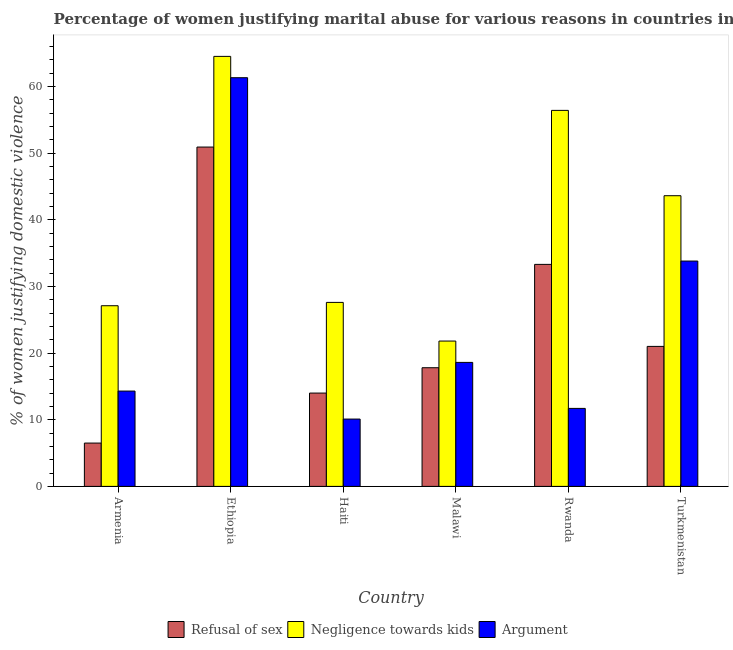How many different coloured bars are there?
Your answer should be compact. 3. How many groups of bars are there?
Your answer should be compact. 6. How many bars are there on the 6th tick from the right?
Ensure brevity in your answer.  3. What is the label of the 4th group of bars from the left?
Give a very brief answer. Malawi. In how many cases, is the number of bars for a given country not equal to the number of legend labels?
Your response must be concise. 0. What is the percentage of women justifying domestic violence due to arguments in Malawi?
Keep it short and to the point. 18.6. Across all countries, what is the maximum percentage of women justifying domestic violence due to refusal of sex?
Provide a short and direct response. 50.9. In which country was the percentage of women justifying domestic violence due to negligence towards kids maximum?
Your answer should be compact. Ethiopia. In which country was the percentage of women justifying domestic violence due to negligence towards kids minimum?
Offer a terse response. Malawi. What is the total percentage of women justifying domestic violence due to refusal of sex in the graph?
Your answer should be very brief. 143.5. What is the difference between the percentage of women justifying domestic violence due to refusal of sex in Armenia and that in Rwanda?
Give a very brief answer. -26.8. What is the difference between the percentage of women justifying domestic violence due to refusal of sex in Turkmenistan and the percentage of women justifying domestic violence due to arguments in Haiti?
Offer a terse response. 10.9. What is the average percentage of women justifying domestic violence due to refusal of sex per country?
Keep it short and to the point. 23.92. What is the difference between the percentage of women justifying domestic violence due to arguments and percentage of women justifying domestic violence due to refusal of sex in Turkmenistan?
Your answer should be very brief. 12.8. What is the ratio of the percentage of women justifying domestic violence due to arguments in Ethiopia to that in Haiti?
Keep it short and to the point. 6.07. Is the difference between the percentage of women justifying domestic violence due to arguments in Haiti and Turkmenistan greater than the difference between the percentage of women justifying domestic violence due to negligence towards kids in Haiti and Turkmenistan?
Your response must be concise. No. What is the difference between the highest and the lowest percentage of women justifying domestic violence due to refusal of sex?
Your answer should be very brief. 44.4. What does the 1st bar from the left in Rwanda represents?
Make the answer very short. Refusal of sex. What does the 2nd bar from the right in Armenia represents?
Your answer should be compact. Negligence towards kids. Is it the case that in every country, the sum of the percentage of women justifying domestic violence due to refusal of sex and percentage of women justifying domestic violence due to negligence towards kids is greater than the percentage of women justifying domestic violence due to arguments?
Provide a succinct answer. Yes. How many bars are there?
Provide a short and direct response. 18. What is the difference between two consecutive major ticks on the Y-axis?
Your response must be concise. 10. Are the values on the major ticks of Y-axis written in scientific E-notation?
Provide a short and direct response. No. Does the graph contain any zero values?
Keep it short and to the point. No. Does the graph contain grids?
Make the answer very short. No. Where does the legend appear in the graph?
Offer a very short reply. Bottom center. How are the legend labels stacked?
Provide a short and direct response. Horizontal. What is the title of the graph?
Keep it short and to the point. Percentage of women justifying marital abuse for various reasons in countries in 2000. Does "Ages 60+" appear as one of the legend labels in the graph?
Provide a succinct answer. No. What is the label or title of the Y-axis?
Give a very brief answer. % of women justifying domestic violence. What is the % of women justifying domestic violence of Refusal of sex in Armenia?
Your answer should be compact. 6.5. What is the % of women justifying domestic violence in Negligence towards kids in Armenia?
Your response must be concise. 27.1. What is the % of women justifying domestic violence in Refusal of sex in Ethiopia?
Give a very brief answer. 50.9. What is the % of women justifying domestic violence of Negligence towards kids in Ethiopia?
Your response must be concise. 64.5. What is the % of women justifying domestic violence in Argument in Ethiopia?
Make the answer very short. 61.3. What is the % of women justifying domestic violence of Refusal of sex in Haiti?
Ensure brevity in your answer.  14. What is the % of women justifying domestic violence in Negligence towards kids in Haiti?
Keep it short and to the point. 27.6. What is the % of women justifying domestic violence in Refusal of sex in Malawi?
Your answer should be compact. 17.8. What is the % of women justifying domestic violence of Negligence towards kids in Malawi?
Offer a terse response. 21.8. What is the % of women justifying domestic violence of Argument in Malawi?
Give a very brief answer. 18.6. What is the % of women justifying domestic violence of Refusal of sex in Rwanda?
Offer a very short reply. 33.3. What is the % of women justifying domestic violence in Negligence towards kids in Rwanda?
Give a very brief answer. 56.4. What is the % of women justifying domestic violence in Argument in Rwanda?
Keep it short and to the point. 11.7. What is the % of women justifying domestic violence of Refusal of sex in Turkmenistan?
Your response must be concise. 21. What is the % of women justifying domestic violence in Negligence towards kids in Turkmenistan?
Offer a terse response. 43.6. What is the % of women justifying domestic violence of Argument in Turkmenistan?
Provide a short and direct response. 33.8. Across all countries, what is the maximum % of women justifying domestic violence of Refusal of sex?
Your response must be concise. 50.9. Across all countries, what is the maximum % of women justifying domestic violence of Negligence towards kids?
Your answer should be very brief. 64.5. Across all countries, what is the maximum % of women justifying domestic violence of Argument?
Provide a short and direct response. 61.3. Across all countries, what is the minimum % of women justifying domestic violence in Negligence towards kids?
Keep it short and to the point. 21.8. Across all countries, what is the minimum % of women justifying domestic violence of Argument?
Ensure brevity in your answer.  10.1. What is the total % of women justifying domestic violence of Refusal of sex in the graph?
Offer a very short reply. 143.5. What is the total % of women justifying domestic violence in Negligence towards kids in the graph?
Ensure brevity in your answer.  241. What is the total % of women justifying domestic violence in Argument in the graph?
Your response must be concise. 149.8. What is the difference between the % of women justifying domestic violence of Refusal of sex in Armenia and that in Ethiopia?
Your answer should be very brief. -44.4. What is the difference between the % of women justifying domestic violence of Negligence towards kids in Armenia and that in Ethiopia?
Your response must be concise. -37.4. What is the difference between the % of women justifying domestic violence of Argument in Armenia and that in Ethiopia?
Offer a terse response. -47. What is the difference between the % of women justifying domestic violence in Negligence towards kids in Armenia and that in Haiti?
Your answer should be very brief. -0.5. What is the difference between the % of women justifying domestic violence of Argument in Armenia and that in Haiti?
Offer a very short reply. 4.2. What is the difference between the % of women justifying domestic violence in Refusal of sex in Armenia and that in Malawi?
Provide a succinct answer. -11.3. What is the difference between the % of women justifying domestic violence in Negligence towards kids in Armenia and that in Malawi?
Your answer should be very brief. 5.3. What is the difference between the % of women justifying domestic violence of Argument in Armenia and that in Malawi?
Ensure brevity in your answer.  -4.3. What is the difference between the % of women justifying domestic violence of Refusal of sex in Armenia and that in Rwanda?
Provide a succinct answer. -26.8. What is the difference between the % of women justifying domestic violence in Negligence towards kids in Armenia and that in Rwanda?
Ensure brevity in your answer.  -29.3. What is the difference between the % of women justifying domestic violence of Argument in Armenia and that in Rwanda?
Make the answer very short. 2.6. What is the difference between the % of women justifying domestic violence of Refusal of sex in Armenia and that in Turkmenistan?
Give a very brief answer. -14.5. What is the difference between the % of women justifying domestic violence in Negligence towards kids in Armenia and that in Turkmenistan?
Your answer should be compact. -16.5. What is the difference between the % of women justifying domestic violence of Argument in Armenia and that in Turkmenistan?
Offer a very short reply. -19.5. What is the difference between the % of women justifying domestic violence in Refusal of sex in Ethiopia and that in Haiti?
Give a very brief answer. 36.9. What is the difference between the % of women justifying domestic violence of Negligence towards kids in Ethiopia and that in Haiti?
Your response must be concise. 36.9. What is the difference between the % of women justifying domestic violence in Argument in Ethiopia and that in Haiti?
Keep it short and to the point. 51.2. What is the difference between the % of women justifying domestic violence in Refusal of sex in Ethiopia and that in Malawi?
Offer a terse response. 33.1. What is the difference between the % of women justifying domestic violence of Negligence towards kids in Ethiopia and that in Malawi?
Keep it short and to the point. 42.7. What is the difference between the % of women justifying domestic violence of Argument in Ethiopia and that in Malawi?
Provide a short and direct response. 42.7. What is the difference between the % of women justifying domestic violence in Refusal of sex in Ethiopia and that in Rwanda?
Provide a succinct answer. 17.6. What is the difference between the % of women justifying domestic violence of Argument in Ethiopia and that in Rwanda?
Your answer should be very brief. 49.6. What is the difference between the % of women justifying domestic violence in Refusal of sex in Ethiopia and that in Turkmenistan?
Provide a short and direct response. 29.9. What is the difference between the % of women justifying domestic violence in Negligence towards kids in Ethiopia and that in Turkmenistan?
Provide a succinct answer. 20.9. What is the difference between the % of women justifying domestic violence in Argument in Ethiopia and that in Turkmenistan?
Your answer should be compact. 27.5. What is the difference between the % of women justifying domestic violence in Negligence towards kids in Haiti and that in Malawi?
Make the answer very short. 5.8. What is the difference between the % of women justifying domestic violence of Refusal of sex in Haiti and that in Rwanda?
Offer a terse response. -19.3. What is the difference between the % of women justifying domestic violence in Negligence towards kids in Haiti and that in Rwanda?
Give a very brief answer. -28.8. What is the difference between the % of women justifying domestic violence in Argument in Haiti and that in Rwanda?
Your answer should be very brief. -1.6. What is the difference between the % of women justifying domestic violence of Argument in Haiti and that in Turkmenistan?
Provide a short and direct response. -23.7. What is the difference between the % of women justifying domestic violence in Refusal of sex in Malawi and that in Rwanda?
Your answer should be compact. -15.5. What is the difference between the % of women justifying domestic violence in Negligence towards kids in Malawi and that in Rwanda?
Provide a short and direct response. -34.6. What is the difference between the % of women justifying domestic violence in Argument in Malawi and that in Rwanda?
Provide a succinct answer. 6.9. What is the difference between the % of women justifying domestic violence in Negligence towards kids in Malawi and that in Turkmenistan?
Your answer should be compact. -21.8. What is the difference between the % of women justifying domestic violence in Argument in Malawi and that in Turkmenistan?
Make the answer very short. -15.2. What is the difference between the % of women justifying domestic violence in Negligence towards kids in Rwanda and that in Turkmenistan?
Provide a succinct answer. 12.8. What is the difference between the % of women justifying domestic violence of Argument in Rwanda and that in Turkmenistan?
Provide a succinct answer. -22.1. What is the difference between the % of women justifying domestic violence in Refusal of sex in Armenia and the % of women justifying domestic violence in Negligence towards kids in Ethiopia?
Ensure brevity in your answer.  -58. What is the difference between the % of women justifying domestic violence in Refusal of sex in Armenia and the % of women justifying domestic violence in Argument in Ethiopia?
Keep it short and to the point. -54.8. What is the difference between the % of women justifying domestic violence of Negligence towards kids in Armenia and the % of women justifying domestic violence of Argument in Ethiopia?
Make the answer very short. -34.2. What is the difference between the % of women justifying domestic violence in Refusal of sex in Armenia and the % of women justifying domestic violence in Negligence towards kids in Haiti?
Make the answer very short. -21.1. What is the difference between the % of women justifying domestic violence in Refusal of sex in Armenia and the % of women justifying domestic violence in Argument in Haiti?
Provide a succinct answer. -3.6. What is the difference between the % of women justifying domestic violence of Negligence towards kids in Armenia and the % of women justifying domestic violence of Argument in Haiti?
Provide a succinct answer. 17. What is the difference between the % of women justifying domestic violence of Refusal of sex in Armenia and the % of women justifying domestic violence of Negligence towards kids in Malawi?
Provide a short and direct response. -15.3. What is the difference between the % of women justifying domestic violence of Refusal of sex in Armenia and the % of women justifying domestic violence of Argument in Malawi?
Provide a succinct answer. -12.1. What is the difference between the % of women justifying domestic violence in Refusal of sex in Armenia and the % of women justifying domestic violence in Negligence towards kids in Rwanda?
Keep it short and to the point. -49.9. What is the difference between the % of women justifying domestic violence in Refusal of sex in Armenia and the % of women justifying domestic violence in Argument in Rwanda?
Your answer should be compact. -5.2. What is the difference between the % of women justifying domestic violence in Negligence towards kids in Armenia and the % of women justifying domestic violence in Argument in Rwanda?
Your response must be concise. 15.4. What is the difference between the % of women justifying domestic violence of Refusal of sex in Armenia and the % of women justifying domestic violence of Negligence towards kids in Turkmenistan?
Provide a short and direct response. -37.1. What is the difference between the % of women justifying domestic violence in Refusal of sex in Armenia and the % of women justifying domestic violence in Argument in Turkmenistan?
Make the answer very short. -27.3. What is the difference between the % of women justifying domestic violence of Negligence towards kids in Armenia and the % of women justifying domestic violence of Argument in Turkmenistan?
Offer a terse response. -6.7. What is the difference between the % of women justifying domestic violence of Refusal of sex in Ethiopia and the % of women justifying domestic violence of Negligence towards kids in Haiti?
Make the answer very short. 23.3. What is the difference between the % of women justifying domestic violence in Refusal of sex in Ethiopia and the % of women justifying domestic violence in Argument in Haiti?
Give a very brief answer. 40.8. What is the difference between the % of women justifying domestic violence in Negligence towards kids in Ethiopia and the % of women justifying domestic violence in Argument in Haiti?
Offer a terse response. 54.4. What is the difference between the % of women justifying domestic violence of Refusal of sex in Ethiopia and the % of women justifying domestic violence of Negligence towards kids in Malawi?
Your response must be concise. 29.1. What is the difference between the % of women justifying domestic violence in Refusal of sex in Ethiopia and the % of women justifying domestic violence in Argument in Malawi?
Your response must be concise. 32.3. What is the difference between the % of women justifying domestic violence in Negligence towards kids in Ethiopia and the % of women justifying domestic violence in Argument in Malawi?
Make the answer very short. 45.9. What is the difference between the % of women justifying domestic violence of Refusal of sex in Ethiopia and the % of women justifying domestic violence of Negligence towards kids in Rwanda?
Give a very brief answer. -5.5. What is the difference between the % of women justifying domestic violence in Refusal of sex in Ethiopia and the % of women justifying domestic violence in Argument in Rwanda?
Provide a succinct answer. 39.2. What is the difference between the % of women justifying domestic violence in Negligence towards kids in Ethiopia and the % of women justifying domestic violence in Argument in Rwanda?
Your answer should be compact. 52.8. What is the difference between the % of women justifying domestic violence of Negligence towards kids in Ethiopia and the % of women justifying domestic violence of Argument in Turkmenistan?
Offer a very short reply. 30.7. What is the difference between the % of women justifying domestic violence of Refusal of sex in Haiti and the % of women justifying domestic violence of Argument in Malawi?
Your answer should be very brief. -4.6. What is the difference between the % of women justifying domestic violence in Negligence towards kids in Haiti and the % of women justifying domestic violence in Argument in Malawi?
Give a very brief answer. 9. What is the difference between the % of women justifying domestic violence in Refusal of sex in Haiti and the % of women justifying domestic violence in Negligence towards kids in Rwanda?
Make the answer very short. -42.4. What is the difference between the % of women justifying domestic violence in Refusal of sex in Haiti and the % of women justifying domestic violence in Argument in Rwanda?
Your answer should be compact. 2.3. What is the difference between the % of women justifying domestic violence of Negligence towards kids in Haiti and the % of women justifying domestic violence of Argument in Rwanda?
Your response must be concise. 15.9. What is the difference between the % of women justifying domestic violence in Refusal of sex in Haiti and the % of women justifying domestic violence in Negligence towards kids in Turkmenistan?
Offer a very short reply. -29.6. What is the difference between the % of women justifying domestic violence in Refusal of sex in Haiti and the % of women justifying domestic violence in Argument in Turkmenistan?
Your answer should be compact. -19.8. What is the difference between the % of women justifying domestic violence in Refusal of sex in Malawi and the % of women justifying domestic violence in Negligence towards kids in Rwanda?
Your answer should be very brief. -38.6. What is the difference between the % of women justifying domestic violence of Refusal of sex in Malawi and the % of women justifying domestic violence of Negligence towards kids in Turkmenistan?
Your response must be concise. -25.8. What is the difference between the % of women justifying domestic violence in Refusal of sex in Rwanda and the % of women justifying domestic violence in Argument in Turkmenistan?
Your response must be concise. -0.5. What is the difference between the % of women justifying domestic violence of Negligence towards kids in Rwanda and the % of women justifying domestic violence of Argument in Turkmenistan?
Offer a very short reply. 22.6. What is the average % of women justifying domestic violence in Refusal of sex per country?
Your answer should be very brief. 23.92. What is the average % of women justifying domestic violence in Negligence towards kids per country?
Offer a terse response. 40.17. What is the average % of women justifying domestic violence of Argument per country?
Give a very brief answer. 24.97. What is the difference between the % of women justifying domestic violence of Refusal of sex and % of women justifying domestic violence of Negligence towards kids in Armenia?
Keep it short and to the point. -20.6. What is the difference between the % of women justifying domestic violence in Negligence towards kids and % of women justifying domestic violence in Argument in Armenia?
Make the answer very short. 12.8. What is the difference between the % of women justifying domestic violence in Refusal of sex and % of women justifying domestic violence in Negligence towards kids in Ethiopia?
Your response must be concise. -13.6. What is the difference between the % of women justifying domestic violence of Refusal of sex and % of women justifying domestic violence of Argument in Ethiopia?
Your response must be concise. -10.4. What is the difference between the % of women justifying domestic violence in Refusal of sex and % of women justifying domestic violence in Argument in Haiti?
Give a very brief answer. 3.9. What is the difference between the % of women justifying domestic violence of Refusal of sex and % of women justifying domestic violence of Negligence towards kids in Malawi?
Your answer should be very brief. -4. What is the difference between the % of women justifying domestic violence in Refusal of sex and % of women justifying domestic violence in Argument in Malawi?
Provide a short and direct response. -0.8. What is the difference between the % of women justifying domestic violence in Negligence towards kids and % of women justifying domestic violence in Argument in Malawi?
Offer a terse response. 3.2. What is the difference between the % of women justifying domestic violence in Refusal of sex and % of women justifying domestic violence in Negligence towards kids in Rwanda?
Your answer should be very brief. -23.1. What is the difference between the % of women justifying domestic violence in Refusal of sex and % of women justifying domestic violence in Argument in Rwanda?
Your answer should be compact. 21.6. What is the difference between the % of women justifying domestic violence in Negligence towards kids and % of women justifying domestic violence in Argument in Rwanda?
Keep it short and to the point. 44.7. What is the difference between the % of women justifying domestic violence of Refusal of sex and % of women justifying domestic violence of Negligence towards kids in Turkmenistan?
Your response must be concise. -22.6. What is the difference between the % of women justifying domestic violence of Refusal of sex and % of women justifying domestic violence of Argument in Turkmenistan?
Provide a short and direct response. -12.8. What is the ratio of the % of women justifying domestic violence in Refusal of sex in Armenia to that in Ethiopia?
Make the answer very short. 0.13. What is the ratio of the % of women justifying domestic violence of Negligence towards kids in Armenia to that in Ethiopia?
Offer a terse response. 0.42. What is the ratio of the % of women justifying domestic violence in Argument in Armenia to that in Ethiopia?
Give a very brief answer. 0.23. What is the ratio of the % of women justifying domestic violence in Refusal of sex in Armenia to that in Haiti?
Your response must be concise. 0.46. What is the ratio of the % of women justifying domestic violence of Negligence towards kids in Armenia to that in Haiti?
Offer a terse response. 0.98. What is the ratio of the % of women justifying domestic violence of Argument in Armenia to that in Haiti?
Your answer should be very brief. 1.42. What is the ratio of the % of women justifying domestic violence of Refusal of sex in Armenia to that in Malawi?
Offer a very short reply. 0.37. What is the ratio of the % of women justifying domestic violence of Negligence towards kids in Armenia to that in Malawi?
Your answer should be very brief. 1.24. What is the ratio of the % of women justifying domestic violence in Argument in Armenia to that in Malawi?
Make the answer very short. 0.77. What is the ratio of the % of women justifying domestic violence in Refusal of sex in Armenia to that in Rwanda?
Your response must be concise. 0.2. What is the ratio of the % of women justifying domestic violence of Negligence towards kids in Armenia to that in Rwanda?
Offer a very short reply. 0.48. What is the ratio of the % of women justifying domestic violence in Argument in Armenia to that in Rwanda?
Provide a succinct answer. 1.22. What is the ratio of the % of women justifying domestic violence in Refusal of sex in Armenia to that in Turkmenistan?
Offer a very short reply. 0.31. What is the ratio of the % of women justifying domestic violence in Negligence towards kids in Armenia to that in Turkmenistan?
Your response must be concise. 0.62. What is the ratio of the % of women justifying domestic violence in Argument in Armenia to that in Turkmenistan?
Ensure brevity in your answer.  0.42. What is the ratio of the % of women justifying domestic violence in Refusal of sex in Ethiopia to that in Haiti?
Your answer should be compact. 3.64. What is the ratio of the % of women justifying domestic violence in Negligence towards kids in Ethiopia to that in Haiti?
Your answer should be very brief. 2.34. What is the ratio of the % of women justifying domestic violence in Argument in Ethiopia to that in Haiti?
Your response must be concise. 6.07. What is the ratio of the % of women justifying domestic violence in Refusal of sex in Ethiopia to that in Malawi?
Keep it short and to the point. 2.86. What is the ratio of the % of women justifying domestic violence in Negligence towards kids in Ethiopia to that in Malawi?
Ensure brevity in your answer.  2.96. What is the ratio of the % of women justifying domestic violence of Argument in Ethiopia to that in Malawi?
Give a very brief answer. 3.3. What is the ratio of the % of women justifying domestic violence in Refusal of sex in Ethiopia to that in Rwanda?
Give a very brief answer. 1.53. What is the ratio of the % of women justifying domestic violence in Negligence towards kids in Ethiopia to that in Rwanda?
Keep it short and to the point. 1.14. What is the ratio of the % of women justifying domestic violence in Argument in Ethiopia to that in Rwanda?
Your response must be concise. 5.24. What is the ratio of the % of women justifying domestic violence in Refusal of sex in Ethiopia to that in Turkmenistan?
Provide a succinct answer. 2.42. What is the ratio of the % of women justifying domestic violence of Negligence towards kids in Ethiopia to that in Turkmenistan?
Your response must be concise. 1.48. What is the ratio of the % of women justifying domestic violence of Argument in Ethiopia to that in Turkmenistan?
Your response must be concise. 1.81. What is the ratio of the % of women justifying domestic violence of Refusal of sex in Haiti to that in Malawi?
Your answer should be compact. 0.79. What is the ratio of the % of women justifying domestic violence of Negligence towards kids in Haiti to that in Malawi?
Your response must be concise. 1.27. What is the ratio of the % of women justifying domestic violence in Argument in Haiti to that in Malawi?
Provide a succinct answer. 0.54. What is the ratio of the % of women justifying domestic violence in Refusal of sex in Haiti to that in Rwanda?
Give a very brief answer. 0.42. What is the ratio of the % of women justifying domestic violence in Negligence towards kids in Haiti to that in Rwanda?
Give a very brief answer. 0.49. What is the ratio of the % of women justifying domestic violence in Argument in Haiti to that in Rwanda?
Your response must be concise. 0.86. What is the ratio of the % of women justifying domestic violence of Refusal of sex in Haiti to that in Turkmenistan?
Offer a terse response. 0.67. What is the ratio of the % of women justifying domestic violence in Negligence towards kids in Haiti to that in Turkmenistan?
Offer a terse response. 0.63. What is the ratio of the % of women justifying domestic violence in Argument in Haiti to that in Turkmenistan?
Give a very brief answer. 0.3. What is the ratio of the % of women justifying domestic violence in Refusal of sex in Malawi to that in Rwanda?
Provide a short and direct response. 0.53. What is the ratio of the % of women justifying domestic violence of Negligence towards kids in Malawi to that in Rwanda?
Offer a terse response. 0.39. What is the ratio of the % of women justifying domestic violence of Argument in Malawi to that in Rwanda?
Make the answer very short. 1.59. What is the ratio of the % of women justifying domestic violence in Refusal of sex in Malawi to that in Turkmenistan?
Provide a short and direct response. 0.85. What is the ratio of the % of women justifying domestic violence of Negligence towards kids in Malawi to that in Turkmenistan?
Your answer should be very brief. 0.5. What is the ratio of the % of women justifying domestic violence in Argument in Malawi to that in Turkmenistan?
Provide a succinct answer. 0.55. What is the ratio of the % of women justifying domestic violence in Refusal of sex in Rwanda to that in Turkmenistan?
Your response must be concise. 1.59. What is the ratio of the % of women justifying domestic violence in Negligence towards kids in Rwanda to that in Turkmenistan?
Your response must be concise. 1.29. What is the ratio of the % of women justifying domestic violence in Argument in Rwanda to that in Turkmenistan?
Your response must be concise. 0.35. What is the difference between the highest and the second highest % of women justifying domestic violence of Refusal of sex?
Make the answer very short. 17.6. What is the difference between the highest and the second highest % of women justifying domestic violence in Argument?
Provide a succinct answer. 27.5. What is the difference between the highest and the lowest % of women justifying domestic violence of Refusal of sex?
Provide a short and direct response. 44.4. What is the difference between the highest and the lowest % of women justifying domestic violence of Negligence towards kids?
Your answer should be very brief. 42.7. What is the difference between the highest and the lowest % of women justifying domestic violence of Argument?
Provide a short and direct response. 51.2. 